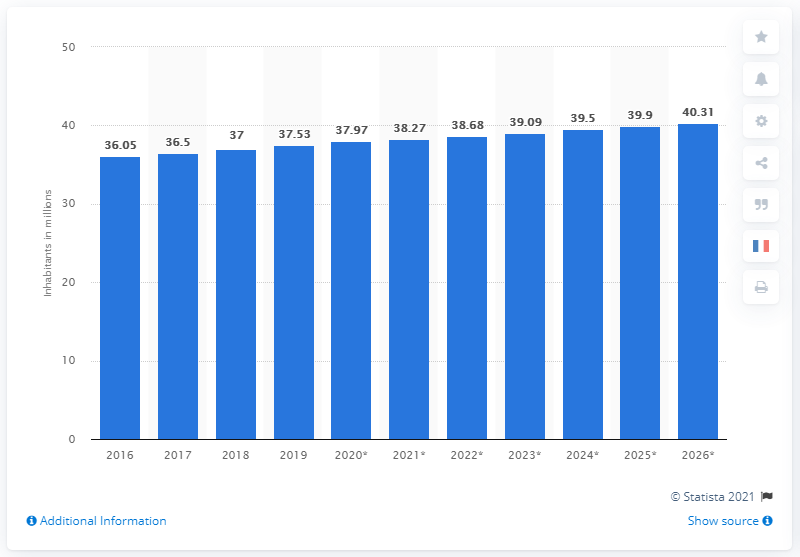Give some essential details in this illustration. In 2019, the population of Canada was approximately 37.53 million people. 